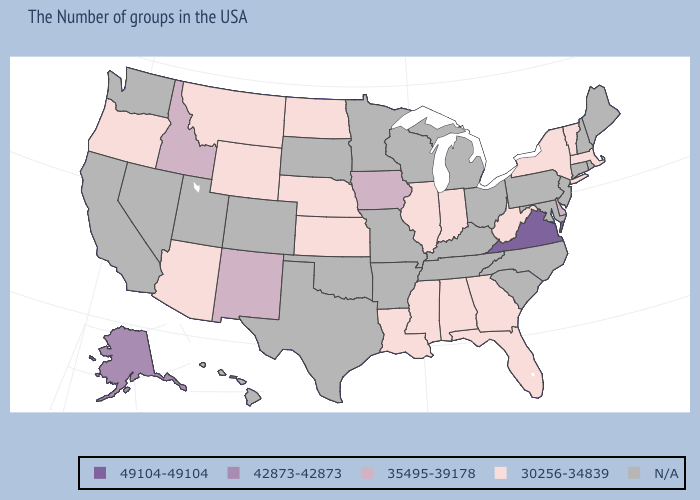Name the states that have a value in the range 42873-42873?
Concise answer only. Alaska. Name the states that have a value in the range 30256-34839?
Keep it brief. Massachusetts, Vermont, New York, West Virginia, Florida, Georgia, Indiana, Alabama, Illinois, Mississippi, Louisiana, Kansas, Nebraska, North Dakota, Wyoming, Montana, Arizona, Oregon. Is the legend a continuous bar?
Be succinct. No. What is the lowest value in states that border Texas?
Concise answer only. 30256-34839. What is the value of Iowa?
Be succinct. 35495-39178. Name the states that have a value in the range 30256-34839?
Give a very brief answer. Massachusetts, Vermont, New York, West Virginia, Florida, Georgia, Indiana, Alabama, Illinois, Mississippi, Louisiana, Kansas, Nebraska, North Dakota, Wyoming, Montana, Arizona, Oregon. Name the states that have a value in the range 35495-39178?
Answer briefly. Delaware, Iowa, New Mexico, Idaho. Does Iowa have the lowest value in the USA?
Answer briefly. No. What is the value of New Mexico?
Write a very short answer. 35495-39178. Among the states that border Alabama , which have the highest value?
Short answer required. Florida, Georgia, Mississippi. What is the value of South Dakota?
Short answer required. N/A. Does Virginia have the highest value in the South?
Keep it brief. Yes. Does the first symbol in the legend represent the smallest category?
Give a very brief answer. No. What is the lowest value in the USA?
Write a very short answer. 30256-34839. 